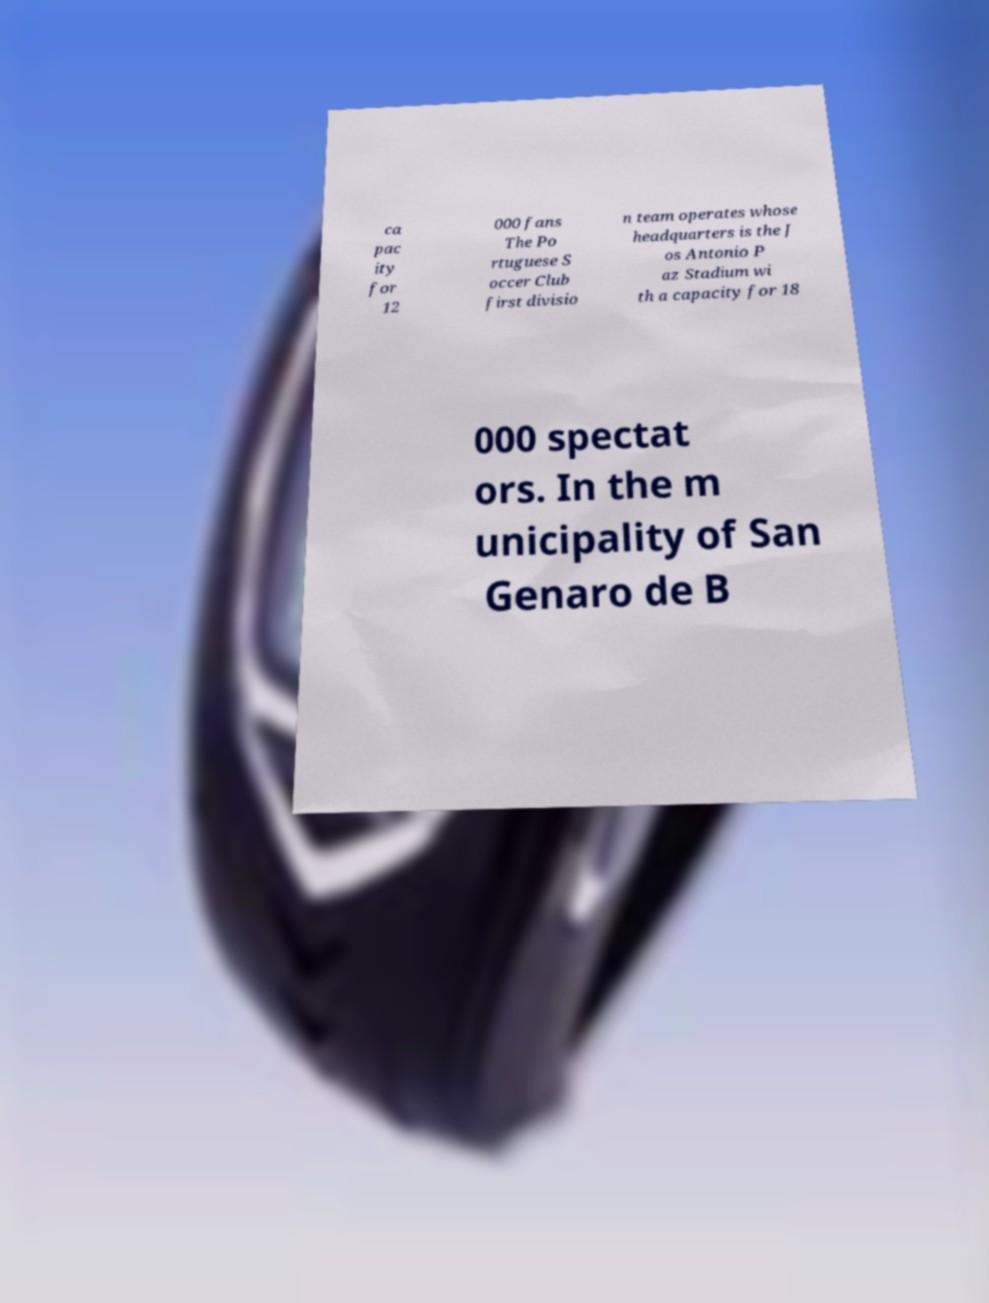Can you accurately transcribe the text from the provided image for me? ca pac ity for 12 000 fans The Po rtuguese S occer Club first divisio n team operates whose headquarters is the J os Antonio P az Stadium wi th a capacity for 18 000 spectat ors. In the m unicipality of San Genaro de B 